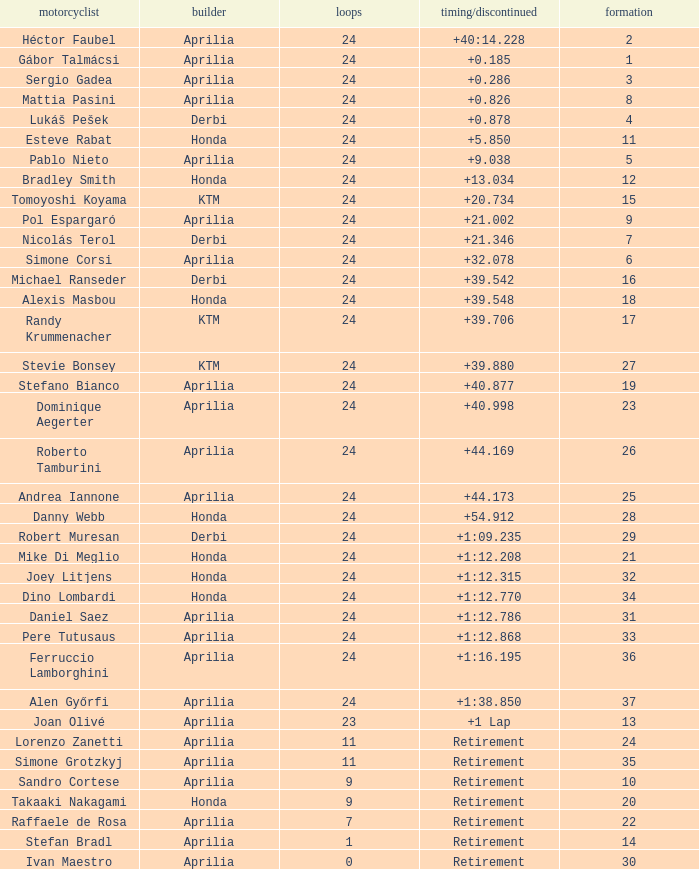How many grids have more than 24 laps with a time/retired of +1:12.208? None. 